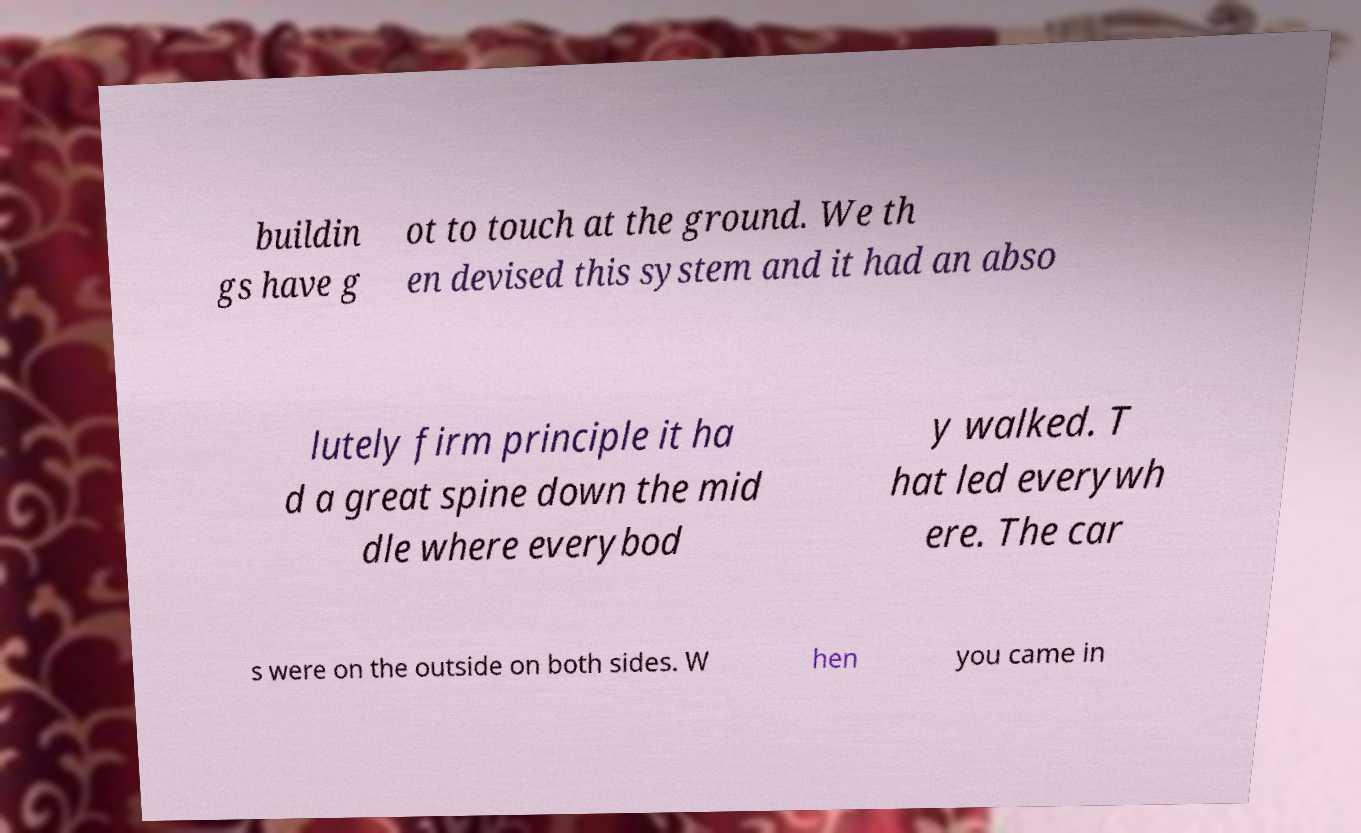There's text embedded in this image that I need extracted. Can you transcribe it verbatim? buildin gs have g ot to touch at the ground. We th en devised this system and it had an abso lutely firm principle it ha d a great spine down the mid dle where everybod y walked. T hat led everywh ere. The car s were on the outside on both sides. W hen you came in 